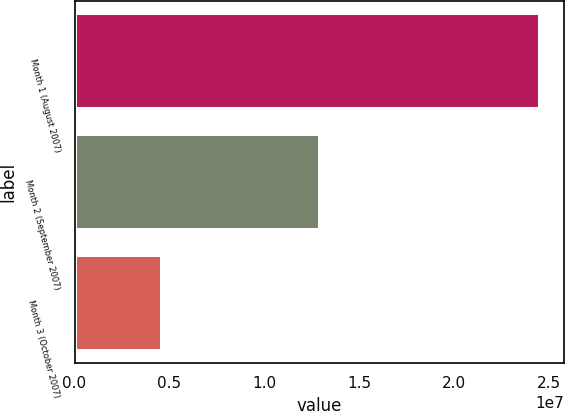Convert chart. <chart><loc_0><loc_0><loc_500><loc_500><bar_chart><fcel>Month 1 (August 2007)<fcel>Month 2 (September 2007)<fcel>Month 3 (October 2007)<nl><fcel>2.4543e+07<fcel>1.29457e+07<fcel>4.6e+06<nl></chart> 